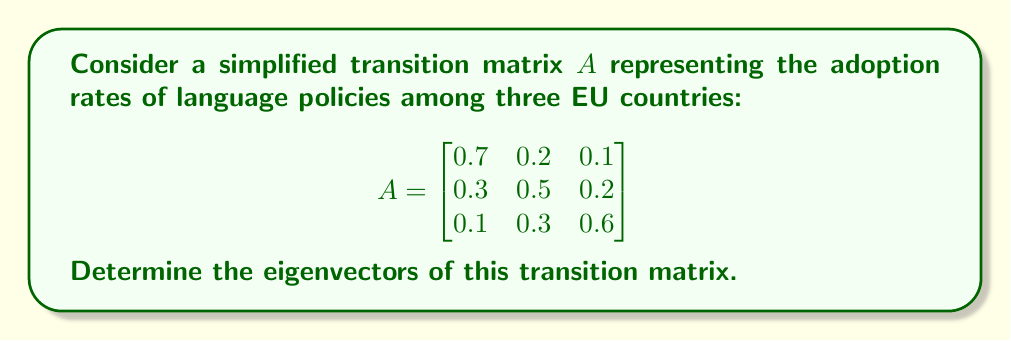Can you answer this question? To find the eigenvectors of matrix $A$, we follow these steps:

1) First, we need to find the eigenvalues by solving the characteristic equation:
   $\det(A - \lambda I) = 0$

2) Expanding the determinant:
   $$\begin{vmatrix}
   0.7-\lambda & 0.2 & 0.1 \\
   0.3 & 0.5-\lambda & 0.2 \\
   0.1 & 0.3 & 0.6-\lambda
   \end{vmatrix} = 0$$

3) This gives us the characteristic polynomial:
   $-\lambda^3 + 1.8\lambda^2 - 0.97\lambda + 0.156 = 0$

4) Solving this equation, we get the eigenvalues:
   $\lambda_1 = 1$, $\lambda_2 = 0.5$, $\lambda_3 = 0.3$

5) For each eigenvalue, we solve $(A - \lambda I)v = 0$ to find the corresponding eigenvector:

   For $\lambda_1 = 1$:
   $$\begin{bmatrix}
   -0.3 & 0.2 & 0.1 \\
   0.3 & -0.5 & 0.2 \\
   0.1 & 0.3 & -0.4
   \end{bmatrix}\begin{bmatrix}v_1 \\ v_2 \\ v_3\end{bmatrix} = \begin{bmatrix}0 \\ 0 \\ 0\end{bmatrix}$$

   Solving this system gives us: $v_1 = \begin{bmatrix}5 \\ 3 \\ 2\end{bmatrix}$

   For $\lambda_2 = 0.5$:
   $$\begin{bmatrix}
   0.2 & 0.2 & 0.1 \\
   0.3 & 0 & 0.2 \\
   0.1 & 0.3 & 0.1
   \end{bmatrix}\begin{bmatrix}v_1 \\ v_2 \\ v_3\end{bmatrix} = \begin{bmatrix}0 \\ 0 \\ 0\end{bmatrix}$$

   Solving this system gives us: $v_2 = \begin{bmatrix}-1 \\ 1 \\ -1\end{bmatrix}$

   For $\lambda_3 = 0.3$:
   $$\begin{bmatrix}
   0.4 & 0.2 & 0.1 \\
   0.3 & 0.2 & 0.2 \\
   0.1 & 0.3 & 0.3
   \end{bmatrix}\begin{bmatrix}v_1 \\ v_2 \\ v_3\end{bmatrix} = \begin{bmatrix}0 \\ 0 \\ 0\end{bmatrix}$$

   Solving this system gives us: $v_3 = \begin{bmatrix}1 \\ -2 \\ 1\end{bmatrix}$
Answer: $v_1 = \begin{bmatrix}5 \\ 3 \\ 2\end{bmatrix}$, $v_2 = \begin{bmatrix}-1 \\ 1 \\ -1\end{bmatrix}$, $v_3 = \begin{bmatrix}1 \\ -2 \\ 1\end{bmatrix}$ 